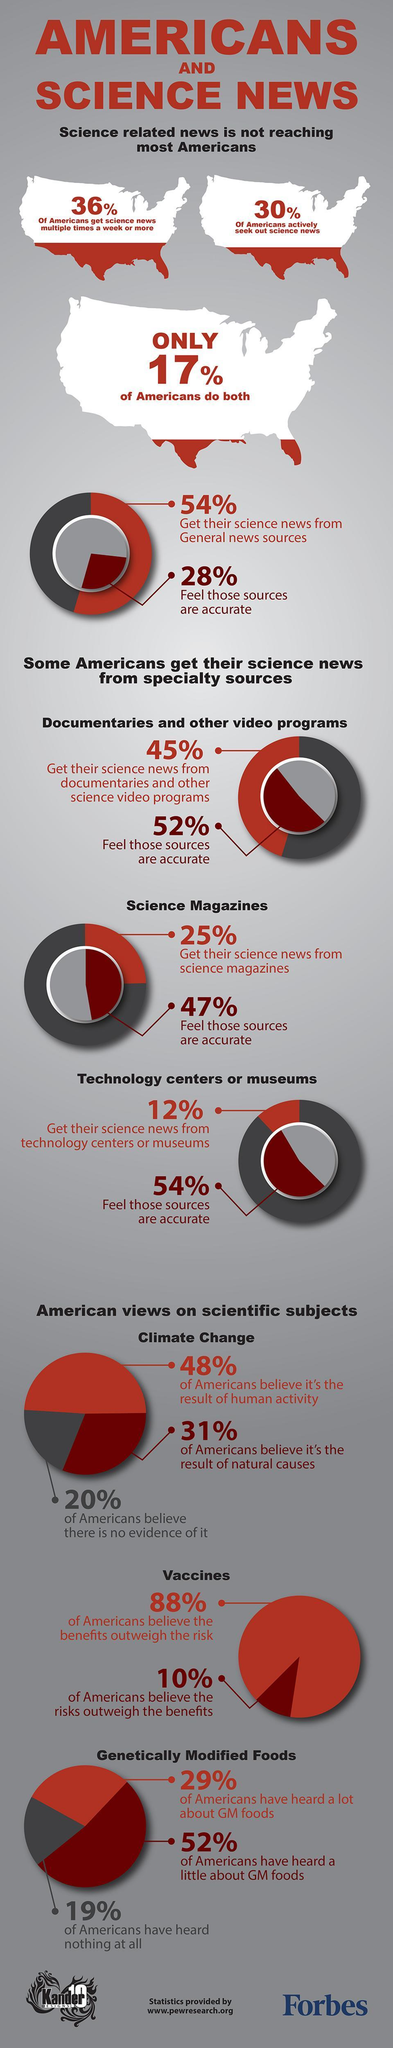What percentage of Americans believe climate change is as a result of natural causes?
Answer the question with a short phrase. 31% What percentage of Americans didn't heard about Genetically Modified Foods? 19% What percentage of Americans actively seek out science news? 30% 